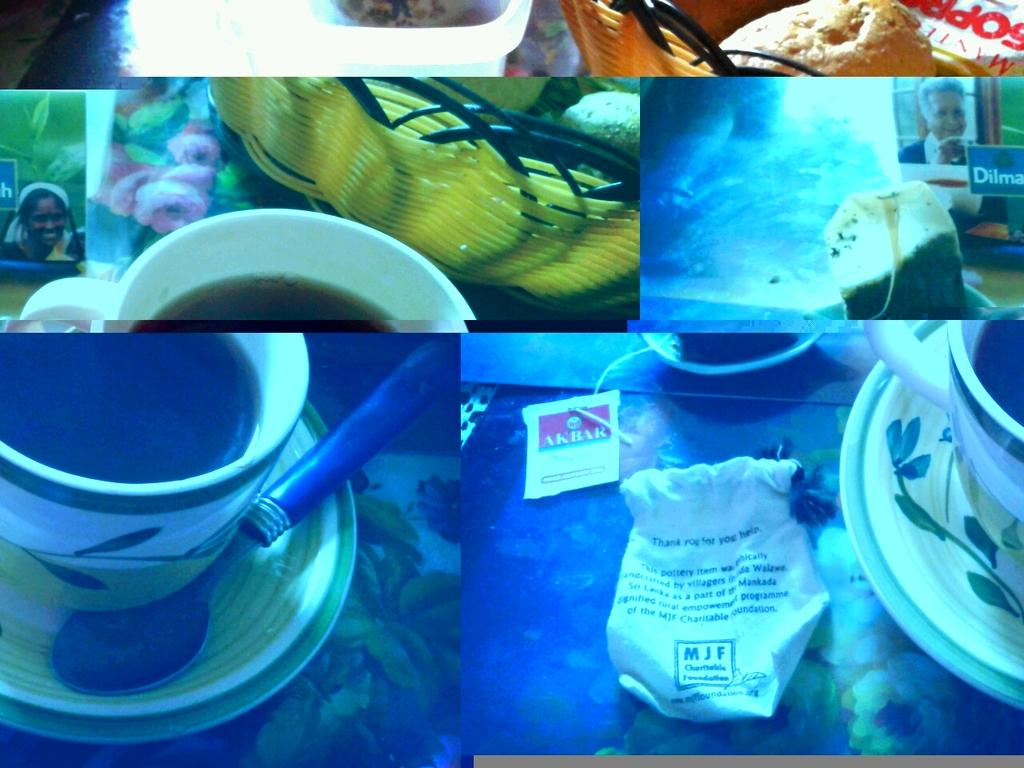What type of artwork is shown in the image? The image is a collage of multiple pictures. Can you describe any specific items in the collage? Yes, there is a cup, a saucer, a spoon, food, and a basket in one of the pictures. Are there any other objects present in the collage? Yes, there are other objects present in the collage. Where is the zebra located in the image? There is no zebra present in the image. Can you tell me how the drain is functioning in the image? There is no drain present in the image. 